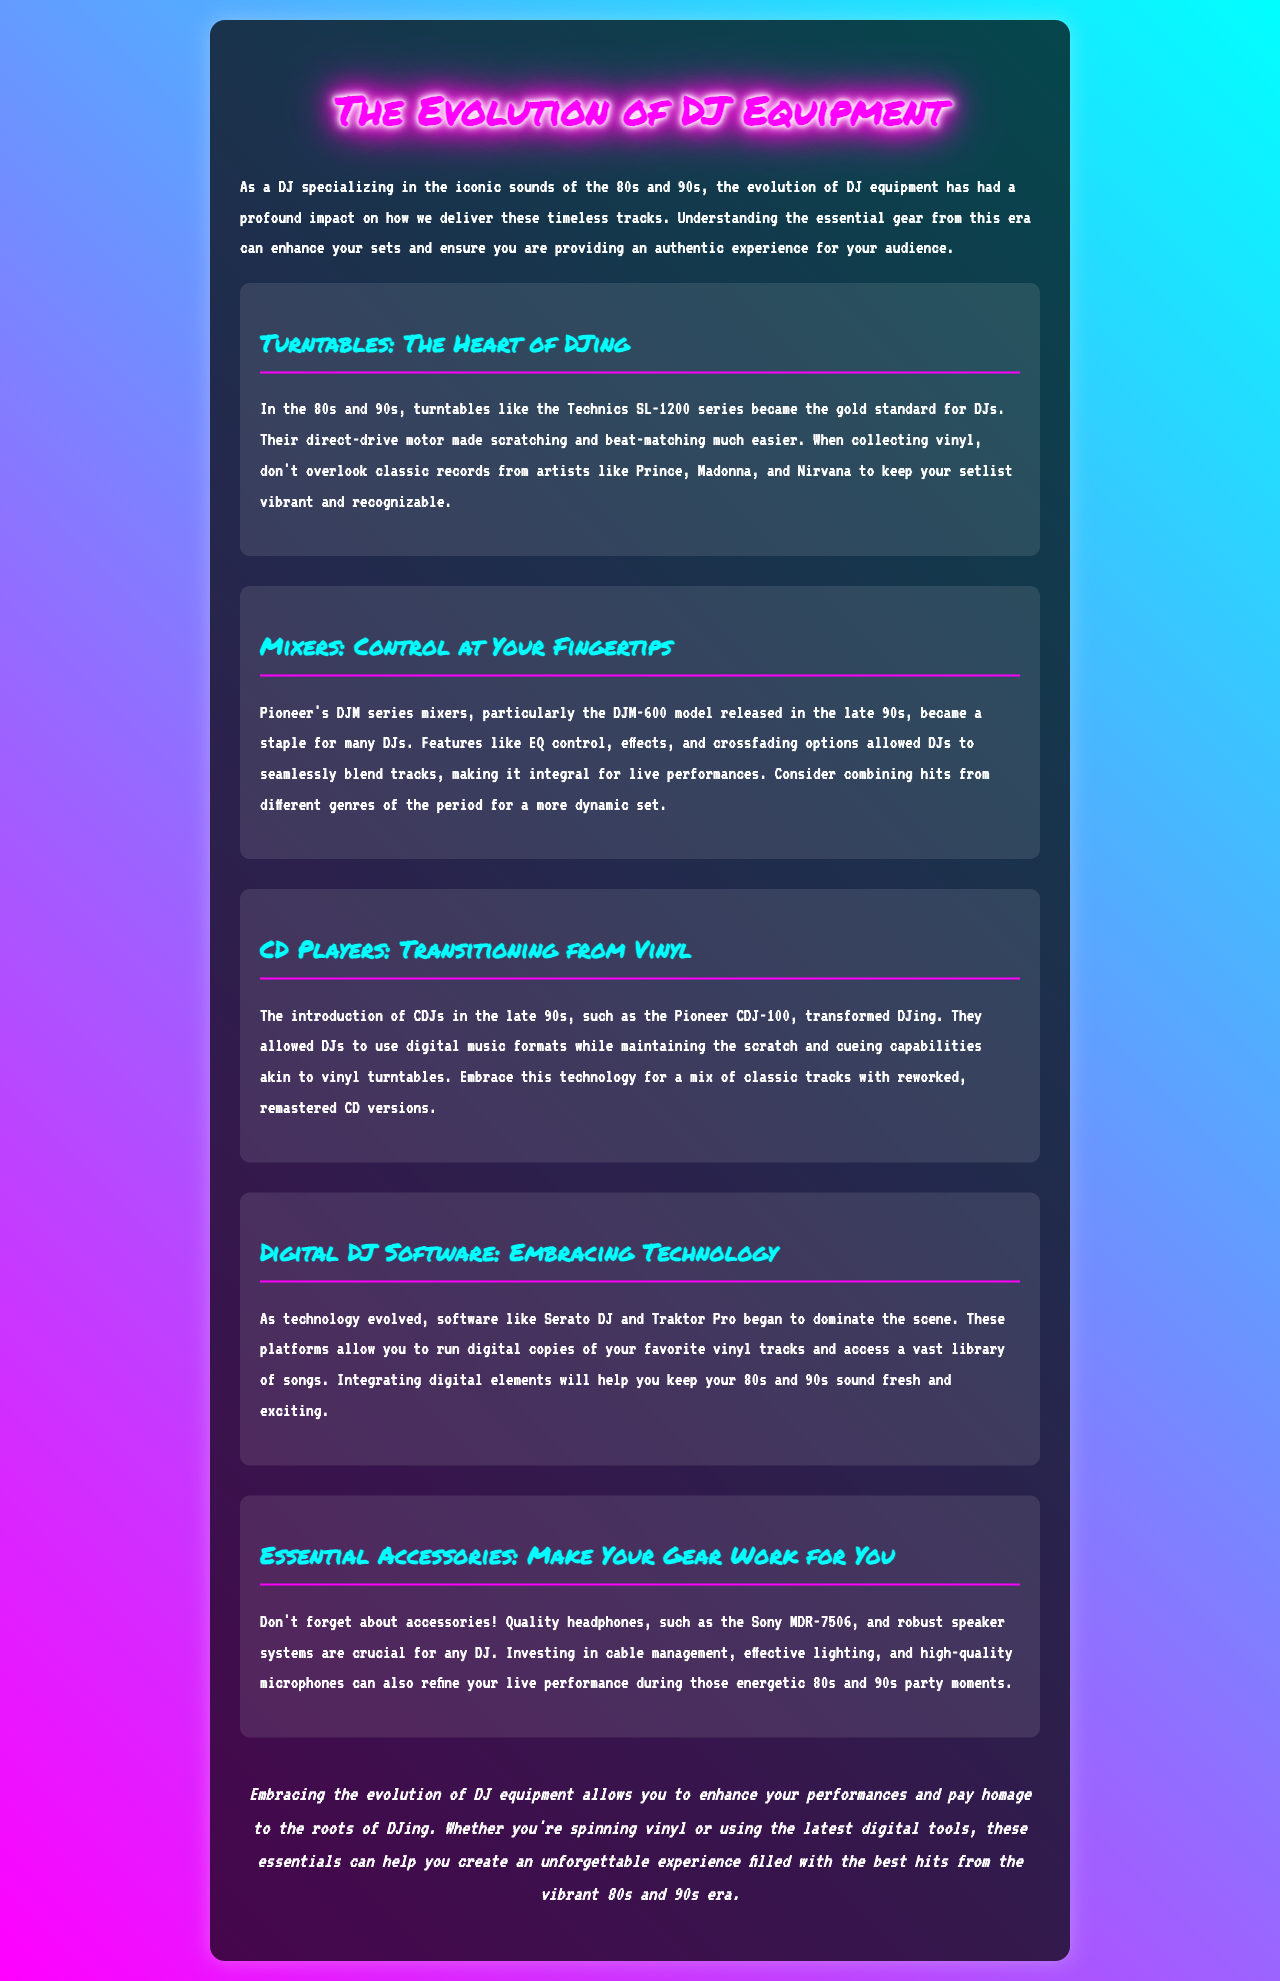What are the gold standard turntables mentioned? The Technics SL-1200 series is highlighted as the gold standard for DJs in the document.
Answer: Technics SL-1200 series Which mixer model is referenced as a staple? The DJM-600 model from Pioneer's DJM series is pointed out as a staple in the late 90s.
Answer: DJM-600 What digital DJ software is mentioned? The document refers to Serato DJ and Traktor Pro as prominent digital DJ software.
Answer: Serato DJ and Traktor Pro What type of headphones is recommended? The document suggests using Sony MDR-7506 headphones as quality equipment for DJs.
Answer: Sony MDR-7506 What technology revolutionized DJing in the late 90s? The introduction of CDJs, particularly the Pioneer CDJ-100, is mentioned as a transformative technology.
Answer: CDJs Why are accessories important for DJs? Accessories help enhance live performances and the overall DJ experience, making them crucial for DJs.
Answer: Enhance live performances How did mixers like the DJM-600 impact live performances? Features like EQ control and crossfading options allowed seamless blending of tracks for DJs.
Answer: Seamless blending What genre of hits should DJs consider combining for a dynamic set? The document suggests combining hits from different genres of the 80s and 90s for more variety.
Answer: Different genres 